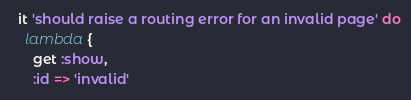<code> <loc_0><loc_0><loc_500><loc_500><_Ruby_>
  it 'should raise a routing error for an invalid page' do
    lambda {
      get :show,
      :id => 'invalid'</code> 